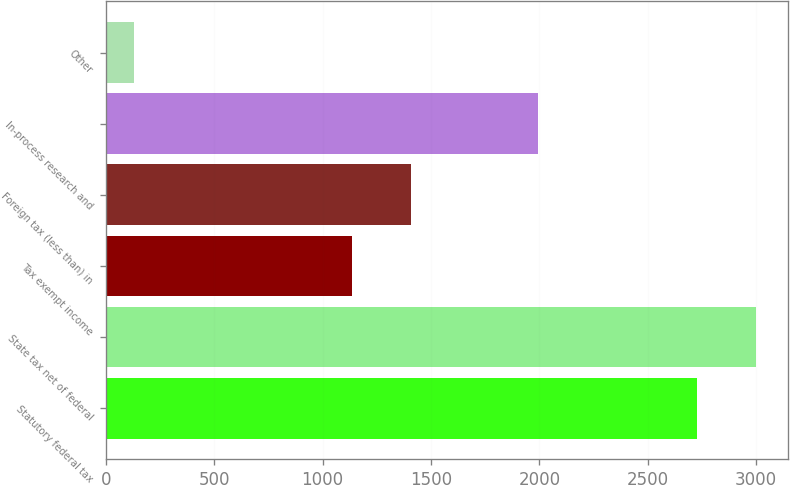<chart> <loc_0><loc_0><loc_500><loc_500><bar_chart><fcel>Statutory federal tax<fcel>State tax net of federal<fcel>Tax exempt income<fcel>Foreign tax (less than) in<fcel>In-process research and<fcel>Other<nl><fcel>2726<fcel>2997.7<fcel>1134<fcel>1405.7<fcel>1995<fcel>129<nl></chart> 